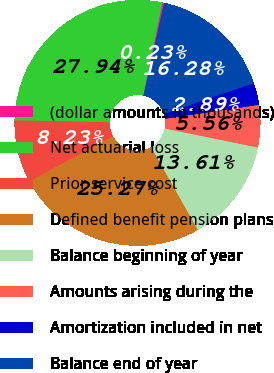Convert chart. <chart><loc_0><loc_0><loc_500><loc_500><pie_chart><fcel>(dollar amounts in thousands)<fcel>Net actuarial loss<fcel>Prior service cost<fcel>Defined benefit pension plans<fcel>Balance beginning of year<fcel>Amounts arising during the<fcel>Amortization included in net<fcel>Balance end of year<nl><fcel>0.23%<fcel>27.94%<fcel>8.23%<fcel>25.27%<fcel>13.61%<fcel>5.56%<fcel>2.89%<fcel>16.28%<nl></chart> 